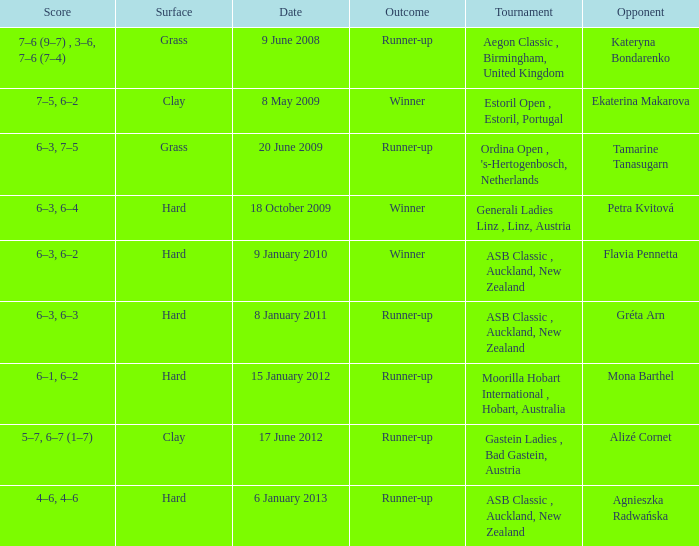What was the score in the tournament against Ekaterina Makarova? 7–5, 6–2. 